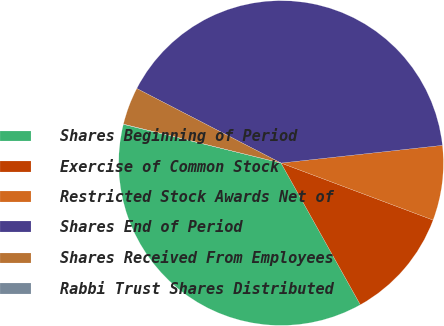<chart> <loc_0><loc_0><loc_500><loc_500><pie_chart><fcel>Shares Beginning of Period<fcel>Exercise of Common Stock<fcel>Restricted Stock Awards Net of<fcel>Shares End of Period<fcel>Shares Received From Employees<fcel>Rabbi Trust Shares Distributed<nl><fcel>36.95%<fcel>11.17%<fcel>7.45%<fcel>40.67%<fcel>3.74%<fcel>0.02%<nl></chart> 